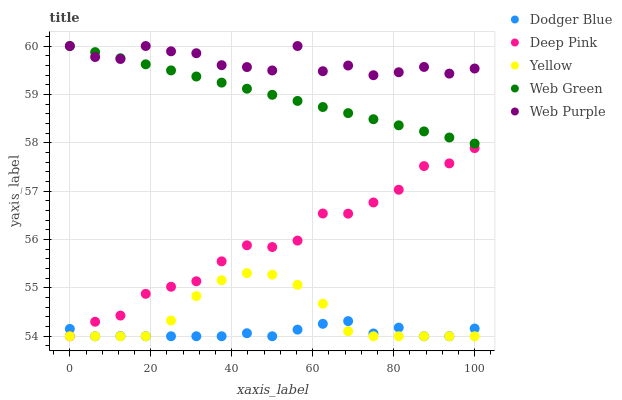Does Dodger Blue have the minimum area under the curve?
Answer yes or no. Yes. Does Web Purple have the maximum area under the curve?
Answer yes or no. Yes. Does Deep Pink have the minimum area under the curve?
Answer yes or no. No. Does Deep Pink have the maximum area under the curve?
Answer yes or no. No. Is Web Green the smoothest?
Answer yes or no. Yes. Is Web Purple the roughest?
Answer yes or no. Yes. Is Deep Pink the smoothest?
Answer yes or no. No. Is Deep Pink the roughest?
Answer yes or no. No. Does Deep Pink have the lowest value?
Answer yes or no. Yes. Does Web Green have the lowest value?
Answer yes or no. No. Does Web Green have the highest value?
Answer yes or no. Yes. Does Deep Pink have the highest value?
Answer yes or no. No. Is Deep Pink less than Web Green?
Answer yes or no. Yes. Is Web Green greater than Yellow?
Answer yes or no. Yes. Does Deep Pink intersect Dodger Blue?
Answer yes or no. Yes. Is Deep Pink less than Dodger Blue?
Answer yes or no. No. Is Deep Pink greater than Dodger Blue?
Answer yes or no. No. Does Deep Pink intersect Web Green?
Answer yes or no. No. 